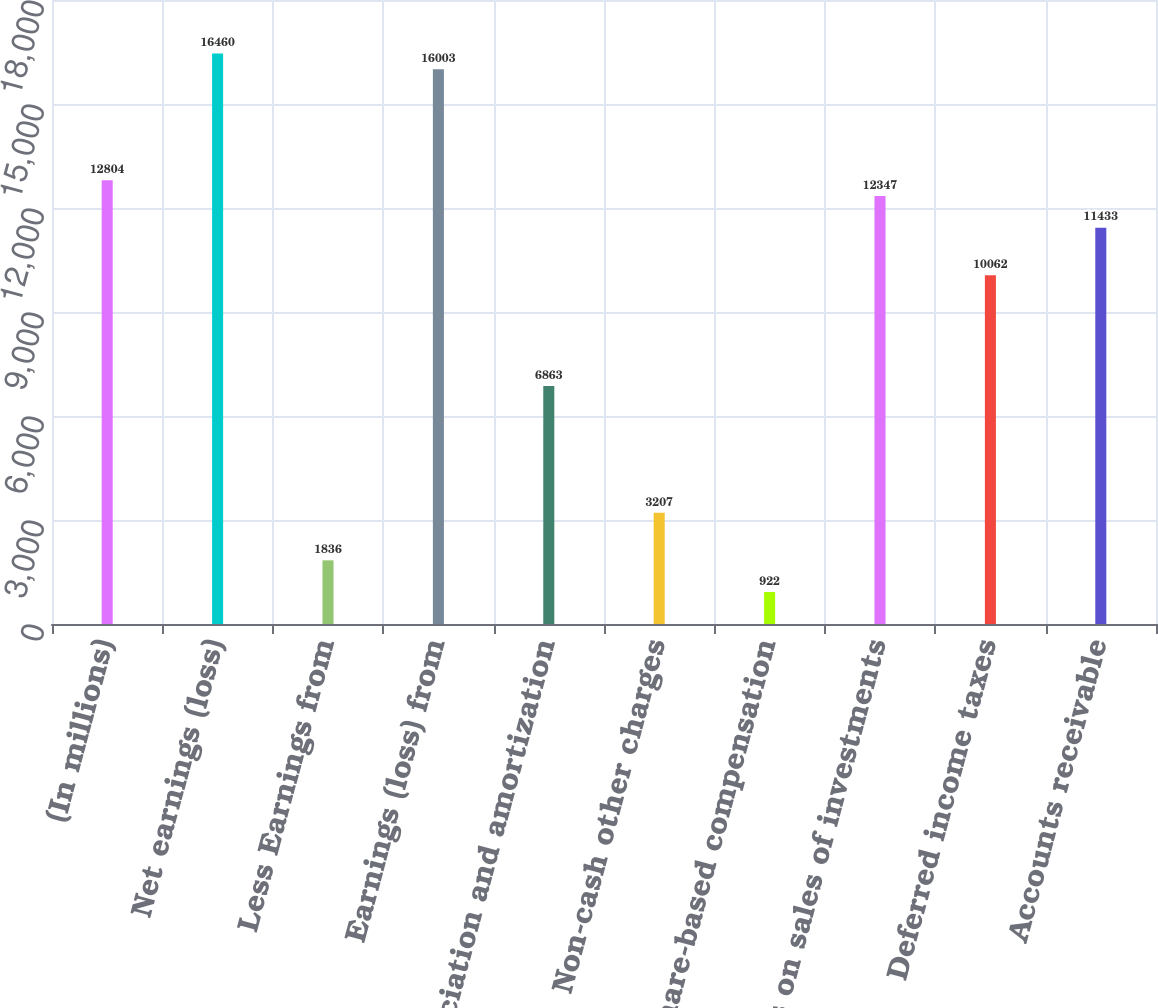Convert chart. <chart><loc_0><loc_0><loc_500><loc_500><bar_chart><fcel>(In millions)<fcel>Net earnings (loss)<fcel>Less Earnings from<fcel>Earnings (loss) from<fcel>Depreciation and amortization<fcel>Non-cash other charges<fcel>Share-based compensation<fcel>Gains on sales of investments<fcel>Deferred income taxes<fcel>Accounts receivable<nl><fcel>12804<fcel>16460<fcel>1836<fcel>16003<fcel>6863<fcel>3207<fcel>922<fcel>12347<fcel>10062<fcel>11433<nl></chart> 